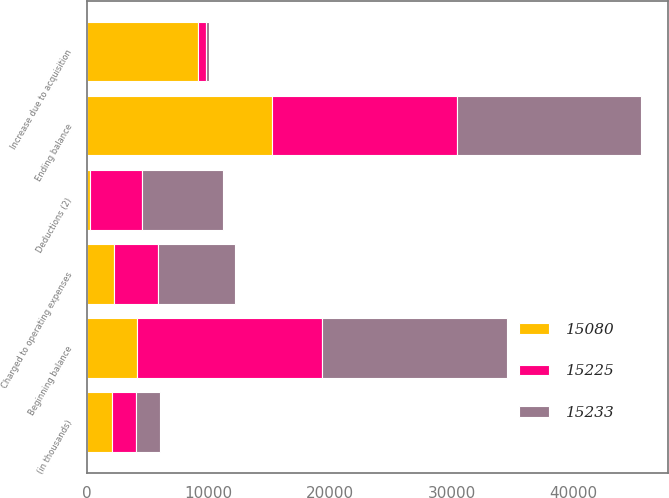Convert chart. <chart><loc_0><loc_0><loc_500><loc_500><stacked_bar_chart><ecel><fcel>(in thousands)<fcel>Beginning balance<fcel>Increase due to acquisition<fcel>Charged to operating expenses<fcel>Deductions (2)<fcel>Ending balance<nl><fcel>15233<fcel>2011<fcel>15233<fcel>269<fcel>6271<fcel>6693<fcel>15080<nl><fcel>15225<fcel>2010<fcel>15225<fcel>662<fcel>3673<fcel>4327<fcel>15233<nl><fcel>15080<fcel>2009<fcel>4128<fcel>9100<fcel>2190<fcel>193<fcel>15225<nl></chart> 